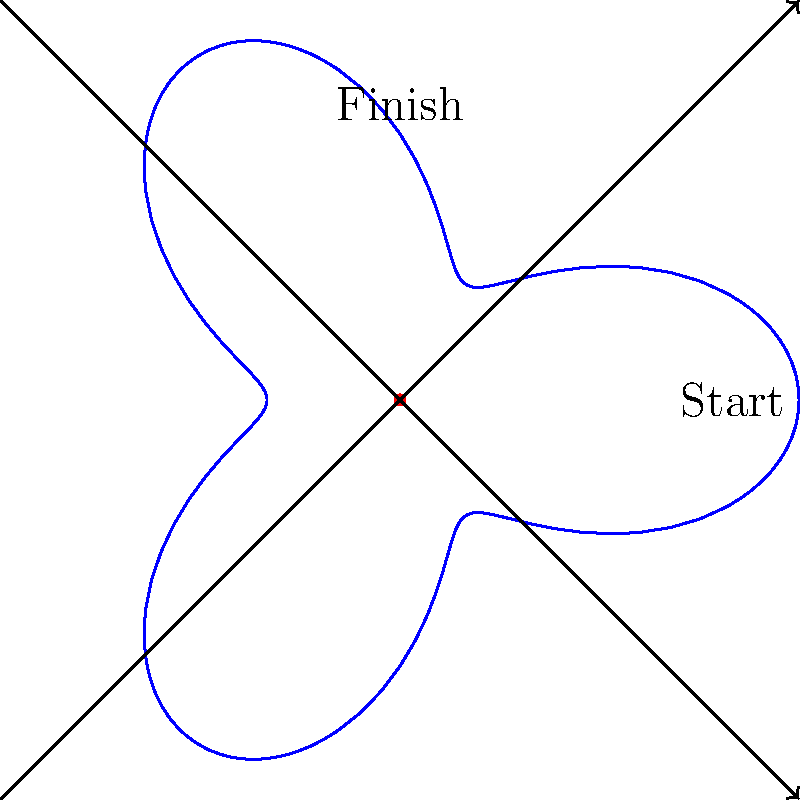Your tractor is stuck in a muddy field, and you need to plot a path to escape. The field's shape can be represented by the polar equation $r = 2 + \cos(3\theta)$. If you start at the point $(2,0)$ and need to reach the point $(0,2)$, what is the shortest angular distance (in radians) you need to travel? Let's approach this step-by-step:

1) The polar equation $r = 2 + \cos(3\theta)$ represents the boundary of the field.

2) We're given two points:
   Start: $(2,0)$ in Cartesian coordinates
   Finish: $(0,2)$ in Cartesian coordinates

3) We need to convert these to polar coordinates:
   Start: $(r,\theta) = (2,0)$
   Finish: $(r,\theta) = (2,\frac{\pi}{2})$

4) The angular distance between these points is the difference in their $\theta$ values:
   $\Delta\theta = \frac{\pi}{2} - 0 = \frac{\pi}{2}$

5) However, we need to consider that we could go clockwise or counterclockwise. The shorter path will be the smaller angle.

6) The clockwise angle is $\frac{\pi}{2}$, and the counterclockwise angle is $2\pi - \frac{\pi}{2} = \frac{3\pi}{2}$.

7) The shorter of these two is $\frac{\pi}{2}$.

Therefore, the shortest angular distance to travel is $\frac{\pi}{2}$ radians.
Answer: $\frac{\pi}{2}$ radians 